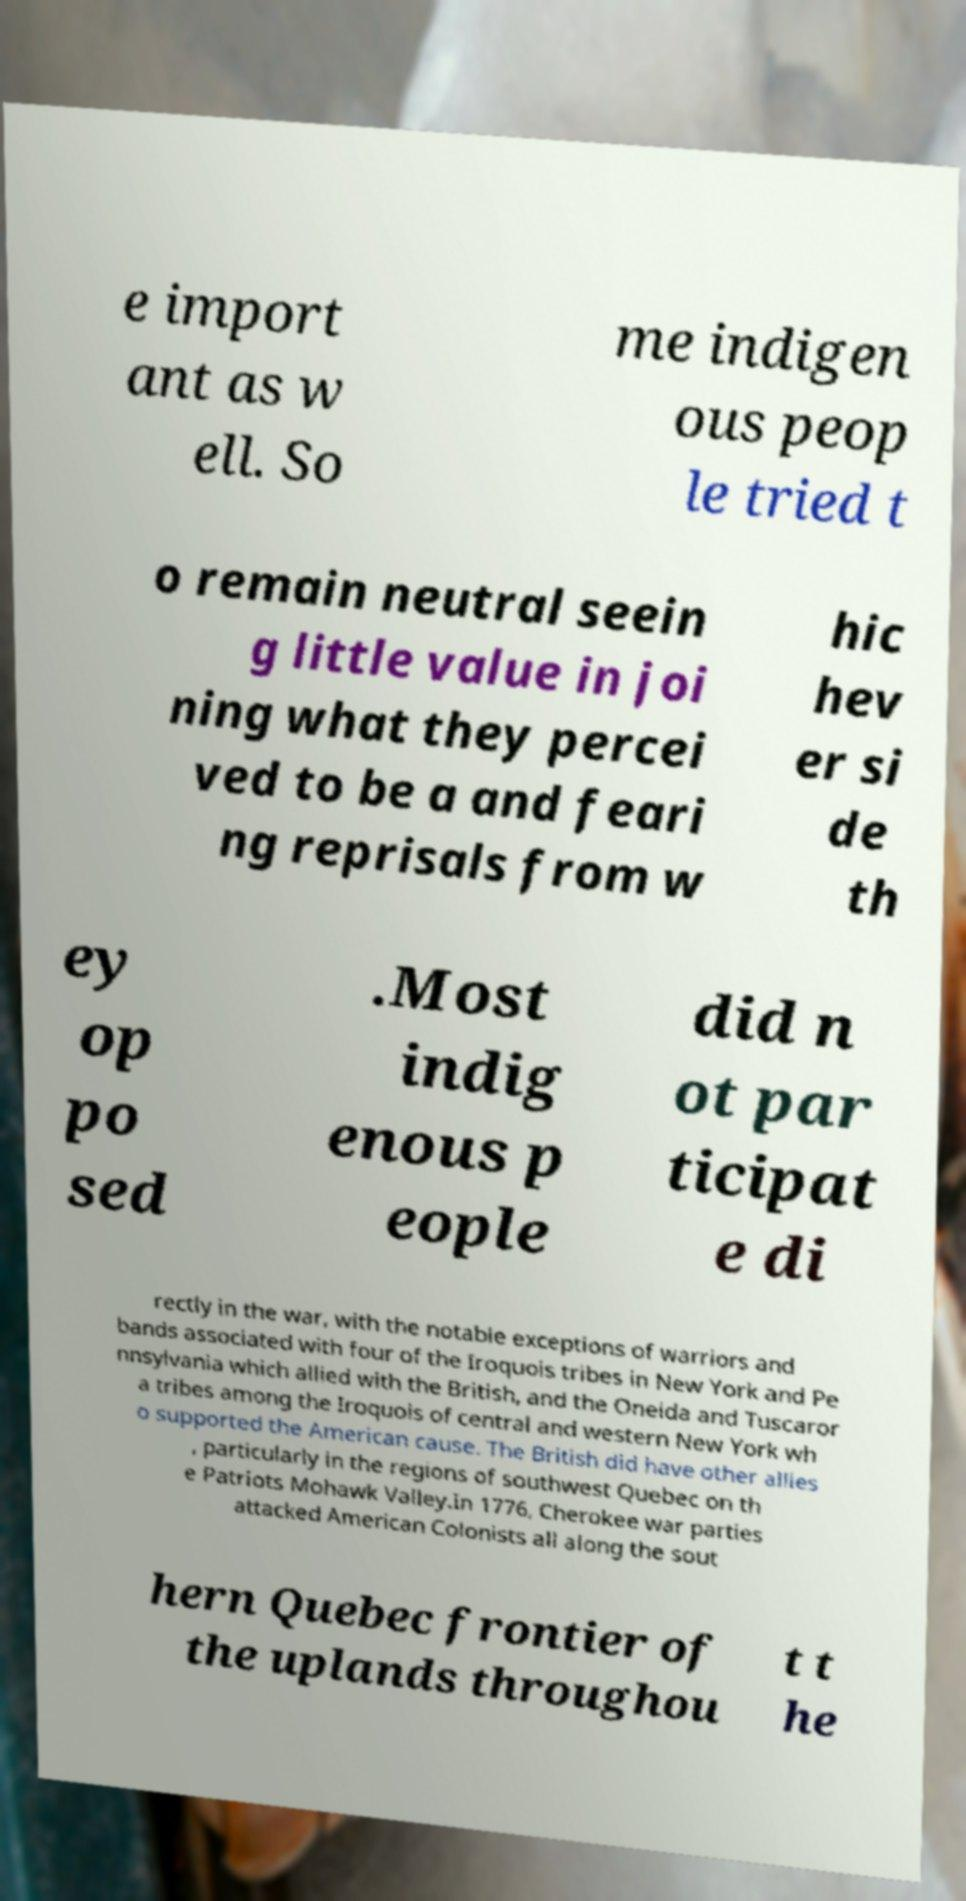Please read and relay the text visible in this image. What does it say? e import ant as w ell. So me indigen ous peop le tried t o remain neutral seein g little value in joi ning what they percei ved to be a and feari ng reprisals from w hic hev er si de th ey op po sed .Most indig enous p eople did n ot par ticipat e di rectly in the war, with the notable exceptions of warriors and bands associated with four of the Iroquois tribes in New York and Pe nnsylvania which allied with the British, and the Oneida and Tuscaror a tribes among the Iroquois of central and western New York wh o supported the American cause. The British did have other allies , particularly in the regions of southwest Quebec on th e Patriots Mohawk Valley.In 1776, Cherokee war parties attacked American Colonists all along the sout hern Quebec frontier of the uplands throughou t t he 